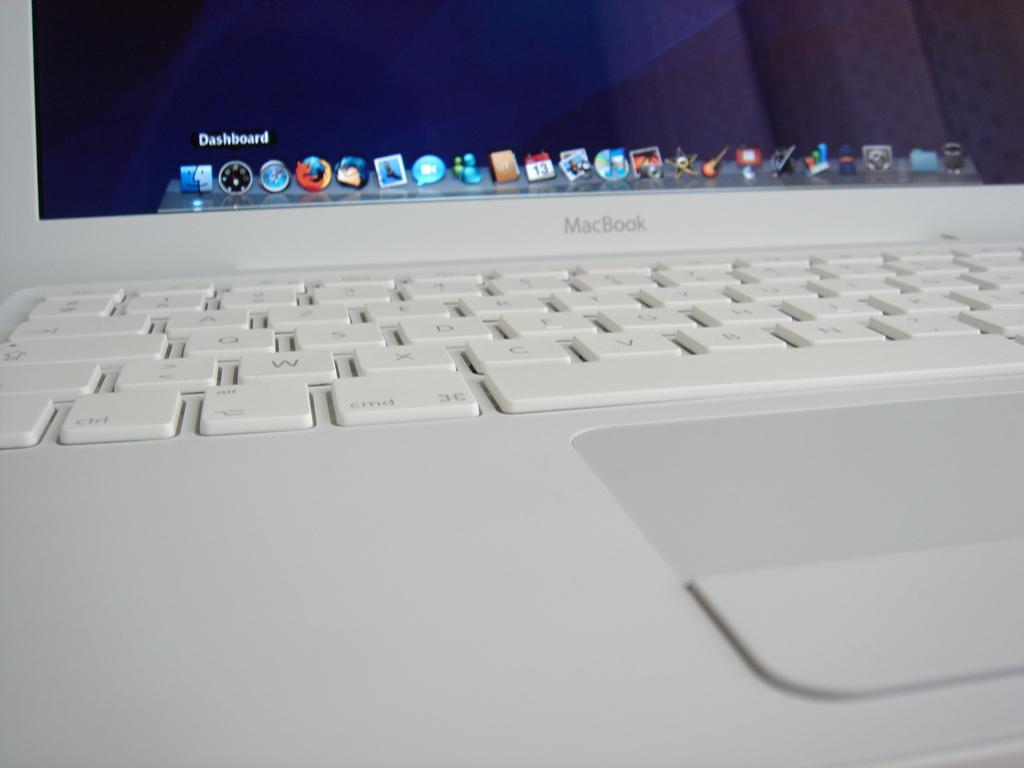<image>
Create a compact narrative representing the image presented. A macbook computer has the word dashboard on the monitor. 